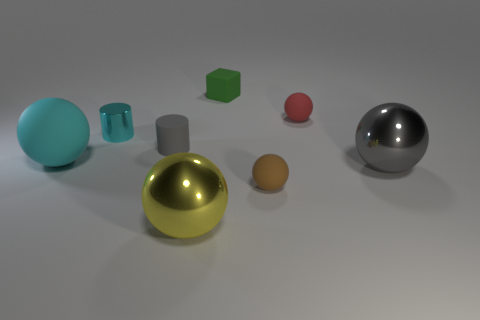Subtract all yellow balls. How many balls are left? 4 Subtract all large yellow metallic spheres. How many spheres are left? 4 Subtract all purple balls. Subtract all gray cubes. How many balls are left? 5 Add 1 big cyan rubber objects. How many objects exist? 9 Subtract all cylinders. How many objects are left? 6 Subtract all tiny cyan cylinders. Subtract all yellow metallic spheres. How many objects are left? 6 Add 2 rubber cylinders. How many rubber cylinders are left? 3 Add 7 tiny purple rubber cylinders. How many tiny purple rubber cylinders exist? 7 Subtract 1 green cubes. How many objects are left? 7 